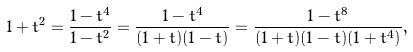<formula> <loc_0><loc_0><loc_500><loc_500>1 + t ^ { 2 } = \frac { 1 - t ^ { 4 } } { 1 - t ^ { 2 } } = \frac { 1 - t ^ { 4 } } { ( 1 + t ) ( 1 - t ) } = \frac { 1 - t ^ { 8 } } { ( 1 + t ) ( 1 - t ) ( 1 + t ^ { 4 } ) } ,</formula> 